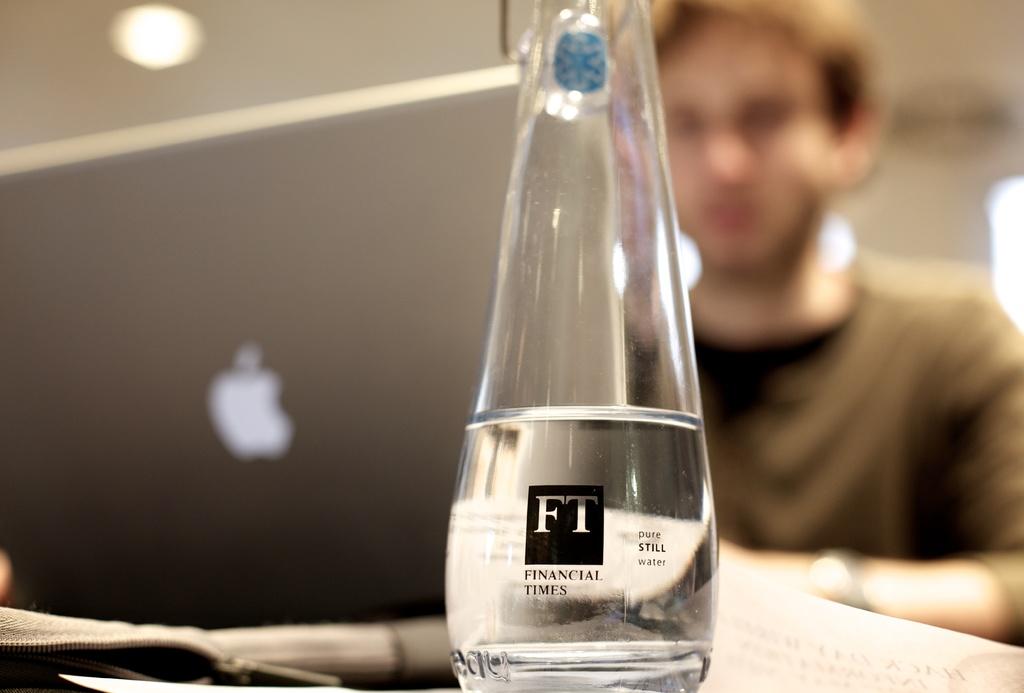What kind of water is in the bottle?
Provide a short and direct response. Pure still water. Is this water still or sparkling?
Give a very brief answer. Still. 